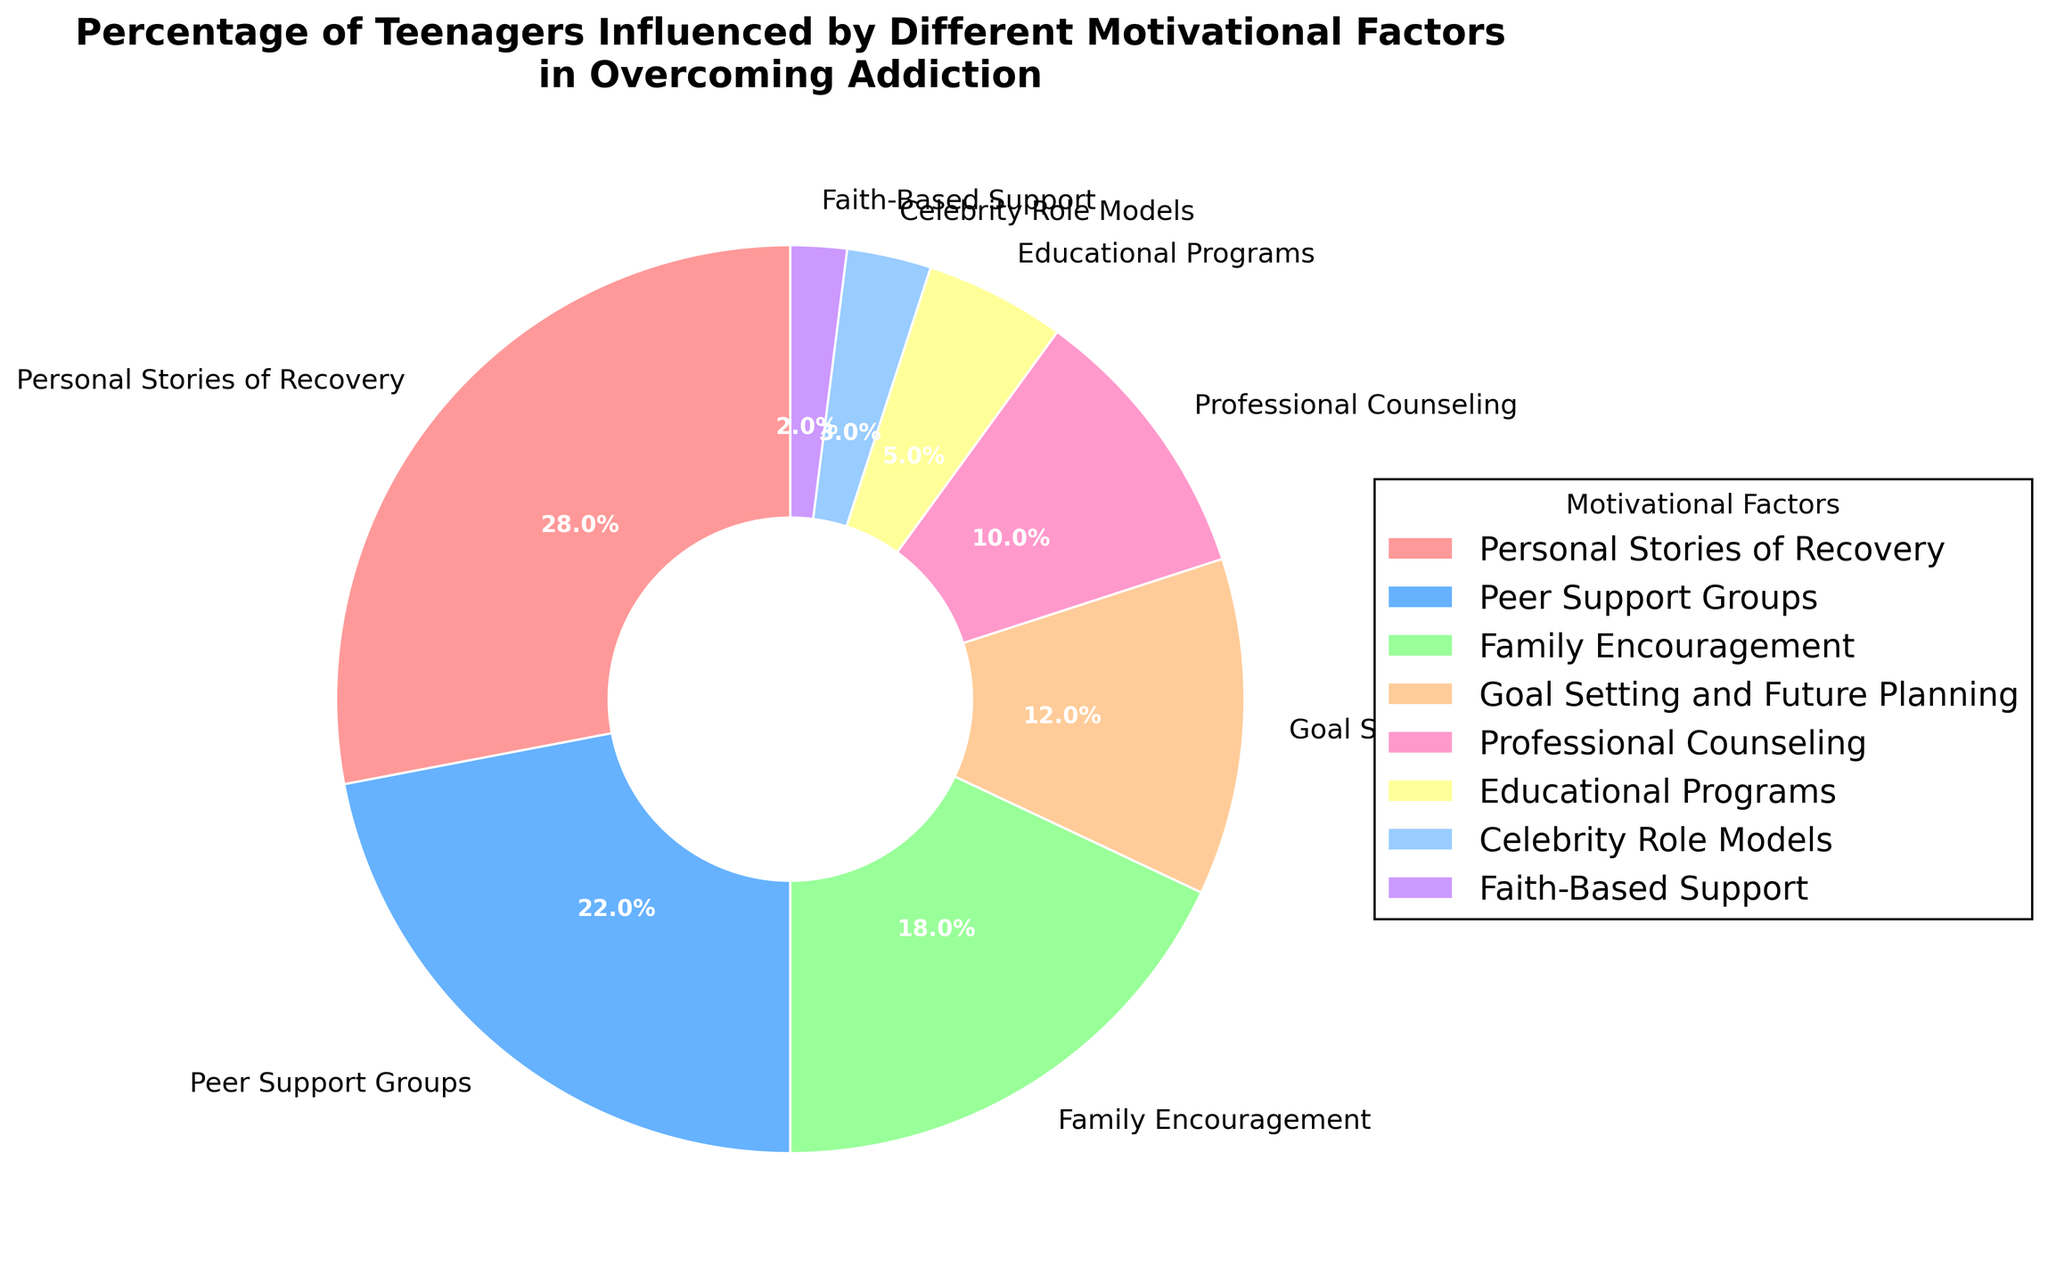What's the most influential motivational factor for teenagers overcoming addiction? The pie chart shows various motivational factors with different percentages. The slice labeled "Personal Stories of Recovery" occupies the largest portion of the chart.
Answer: Personal Stories of Recovery Which two motivational factors combined make up half of the total influence on teenagers overcoming addiction? Summing up the percentages of "Personal Stories of Recovery" (28%) and "Peer Support Groups" (22%) gives 50%.
Answer: Personal Stories of Recovery and Peer Support Groups How much more influential is Family Encouragement compared to Educational Programs? Family Encouragement has a percentage of 18%, while Educational Programs have 5%. Subtracting the latter from the former gives 13%.
Answer: 13% Which motivational factor has the smallest influence and what percentage does it hold? By looking at the smaller slices of the pie chart, the label "Faith-Based Support" can be seen with 2%, which is the smallest percentage.
Answer: Faith-Based Support, 2% Are professional counseling efforts more influential than goal setting and future planning? Comparing the slices "Professional Counseling" at 10% and "Goal Setting and Future Planning" at 12% shows that the latter is slightly more influential.
Answer: No What percentage of teenagers are influenced by Celebrity Role Models and Faith-Based Support combined? Adding the percentages for "Celebrity Role Models" (3%) and "Faith-Based Support" (2%) gives 5%.
Answer: 5% What is the percentage difference between Peer Support Groups and Family Encouragement? The Peer Support Groups percentage is 22%, and Family Encouragement is 18%. Subtracting 18% from 22% gives a 4% difference.
Answer: 4% Which factors together exceed the influence of Professional Counseling? List them. Summing smaller influences to exceed Professional Counseling's 10%: "Educational Programs" (5%) + "Celebrity Role Models" (3%) + "Faith-Based Support" (2%) = 10%.
Answer: Educational Programs, Celebrity Role Models, and Faith-Based Support Which motivational factor occupies a purple-colored segment in the chart? Observing the pie chart's segments, the purple-colored slice corresponds to "Celebrity Role Models".
Answer: Celebrity Role Models What is the combined influence percentage of Goal Setting and Future Planning, and Professional Counseling? Adding "Goal Setting and Future Planning" (12%) and "Professional Counseling" (10%) gives a total of 22%.
Answer: 22% 